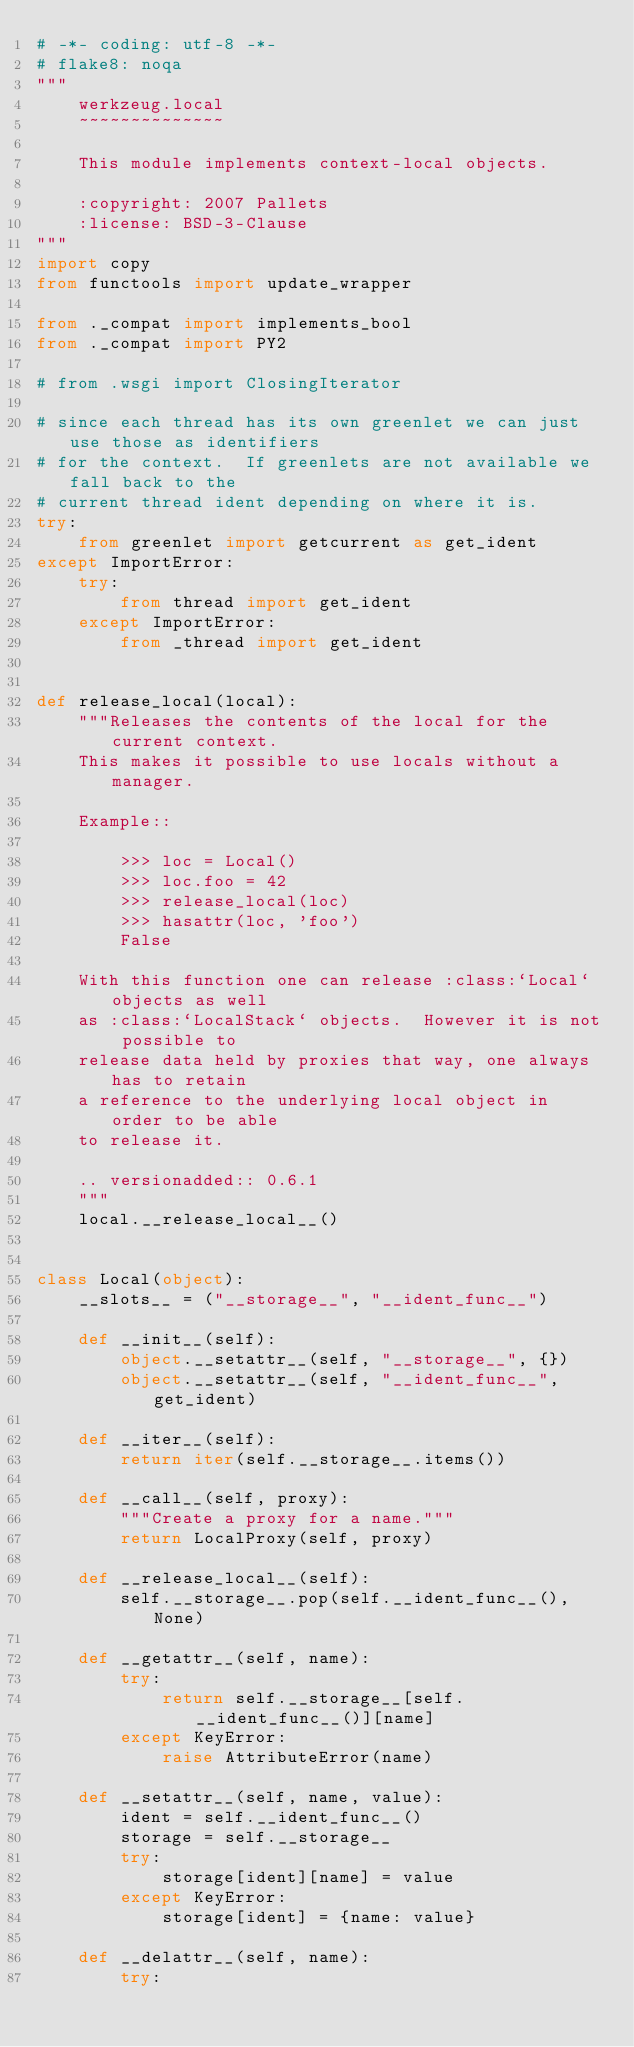Convert code to text. <code><loc_0><loc_0><loc_500><loc_500><_Python_># -*- coding: utf-8 -*-
# flake8: noqa
"""
    werkzeug.local
    ~~~~~~~~~~~~~~

    This module implements context-local objects.

    :copyright: 2007 Pallets
    :license: BSD-3-Clause
"""
import copy
from functools import update_wrapper

from ._compat import implements_bool
from ._compat import PY2

# from .wsgi import ClosingIterator

# since each thread has its own greenlet we can just use those as identifiers
# for the context.  If greenlets are not available we fall back to the
# current thread ident depending on where it is.
try:
    from greenlet import getcurrent as get_ident
except ImportError:
    try:
        from thread import get_ident
    except ImportError:
        from _thread import get_ident


def release_local(local):
    """Releases the contents of the local for the current context.
    This makes it possible to use locals without a manager.

    Example::

        >>> loc = Local()
        >>> loc.foo = 42
        >>> release_local(loc)
        >>> hasattr(loc, 'foo')
        False

    With this function one can release :class:`Local` objects as well
    as :class:`LocalStack` objects.  However it is not possible to
    release data held by proxies that way, one always has to retain
    a reference to the underlying local object in order to be able
    to release it.

    .. versionadded:: 0.6.1
    """
    local.__release_local__()


class Local(object):
    __slots__ = ("__storage__", "__ident_func__")

    def __init__(self):
        object.__setattr__(self, "__storage__", {})
        object.__setattr__(self, "__ident_func__", get_ident)

    def __iter__(self):
        return iter(self.__storage__.items())

    def __call__(self, proxy):
        """Create a proxy for a name."""
        return LocalProxy(self, proxy)

    def __release_local__(self):
        self.__storage__.pop(self.__ident_func__(), None)

    def __getattr__(self, name):
        try:
            return self.__storage__[self.__ident_func__()][name]
        except KeyError:
            raise AttributeError(name)

    def __setattr__(self, name, value):
        ident = self.__ident_func__()
        storage = self.__storage__
        try:
            storage[ident][name] = value
        except KeyError:
            storage[ident] = {name: value}

    def __delattr__(self, name):
        try:</code> 